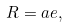Convert formula to latex. <formula><loc_0><loc_0><loc_500><loc_500>R = a e ,</formula> 